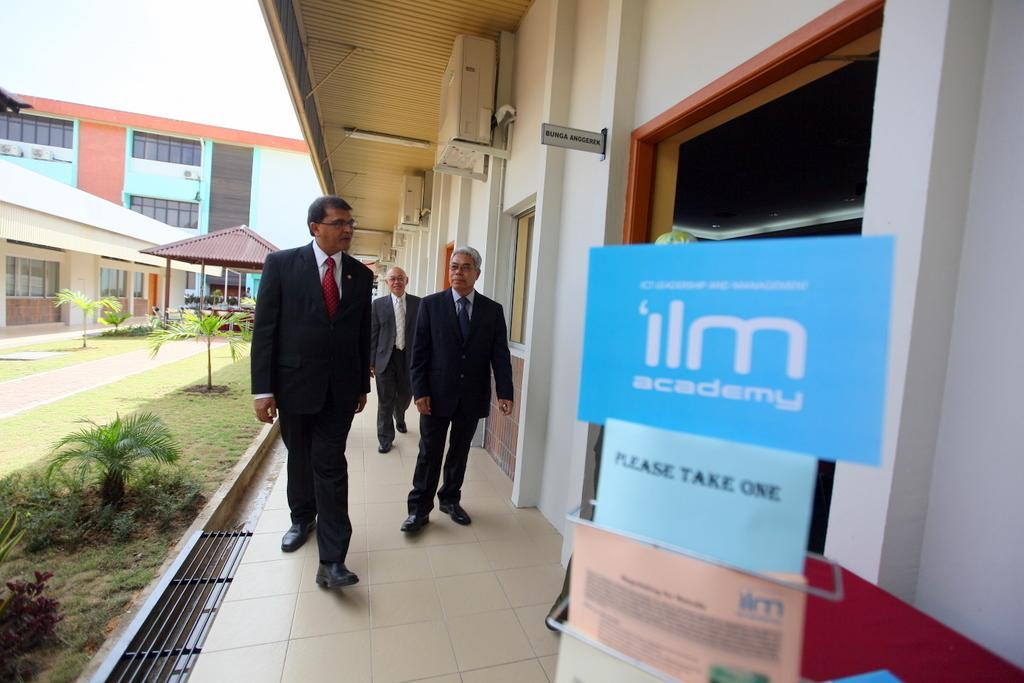Provide a one-sentence caption for the provided image. Three men walking into a room with a stand that has cards that say "Please Take One". 